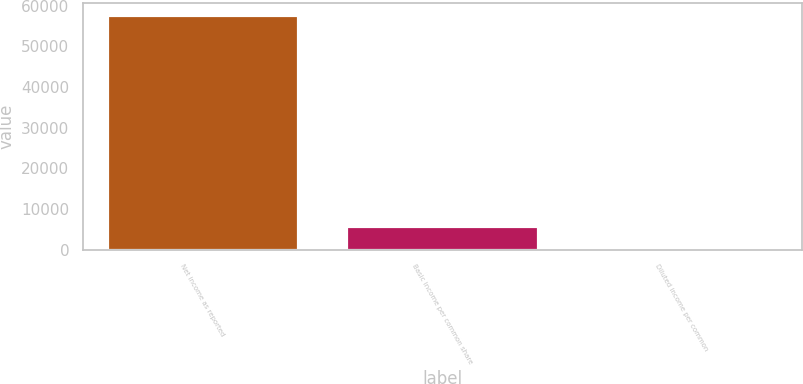Convert chart. <chart><loc_0><loc_0><loc_500><loc_500><bar_chart><fcel>Net income as reported<fcel>Basic income per common share<fcel>Diluted income per common<nl><fcel>57809<fcel>5781.4<fcel>0.56<nl></chart> 